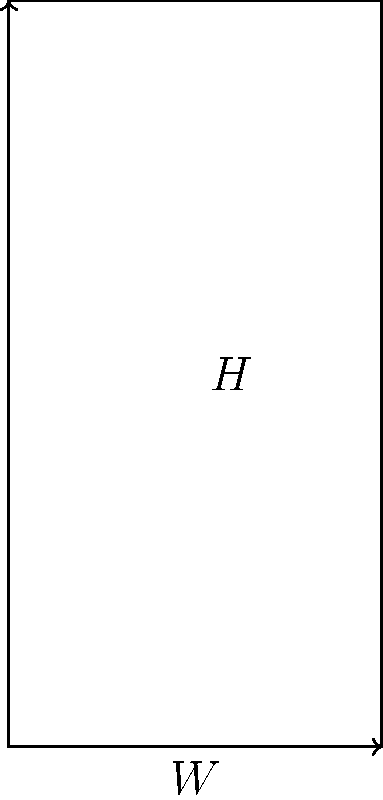As a civic educator, you want to explain building safety regulations to the public. Consider a simplified rectangular building with width $W = 10$ m and a uniform wind load of $P = 2 \text{ kN/m}^2$. The building's foundation can safely resist a maximum overturning moment of $M_{max} = 10,000 \text{ kN}\cdot\text{m}$. What is the maximum allowable height $H$ of the building to ensure it doesn't overturn due to wind load? To solve this problem, we'll follow these steps:

1) First, we need to understand that the wind load creates an overturning moment on the building. This moment is the product of the total force and its lever arm.

2) The total wind force $F$ is the product of the wind pressure $P$, the width $W$, and the height $H$:

   $F = P \cdot W \cdot H = 2 \text{ kN/m}^2 \cdot 10 \text{ m} \cdot H = 20H \text{ kN}$

3) The lever arm for this force is half the height of the building, $H/2$, as the force acts uniformly across the height.

4) The overturning moment $M$ is therefore:

   $M = F \cdot \frac{H}{2} = 20H \cdot \frac{H}{2} = 10H^2 \text{ kN}\cdot\text{m}$

5) We know that this moment must not exceed the maximum allowable moment:

   $10H^2 \leq 10,000 \text{ kN}\cdot\text{m}$

6) Solving this inequality:

   $H^2 \leq 1,000 \text{ m}^2$
   $H \leq \sqrt{1,000} \text{ m} = 31.62 \text{ m}$

7) As height must be a practical, rounded number, we take the floor of this value.

Therefore, the maximum allowable height is 31 m.
Answer: 31 m 